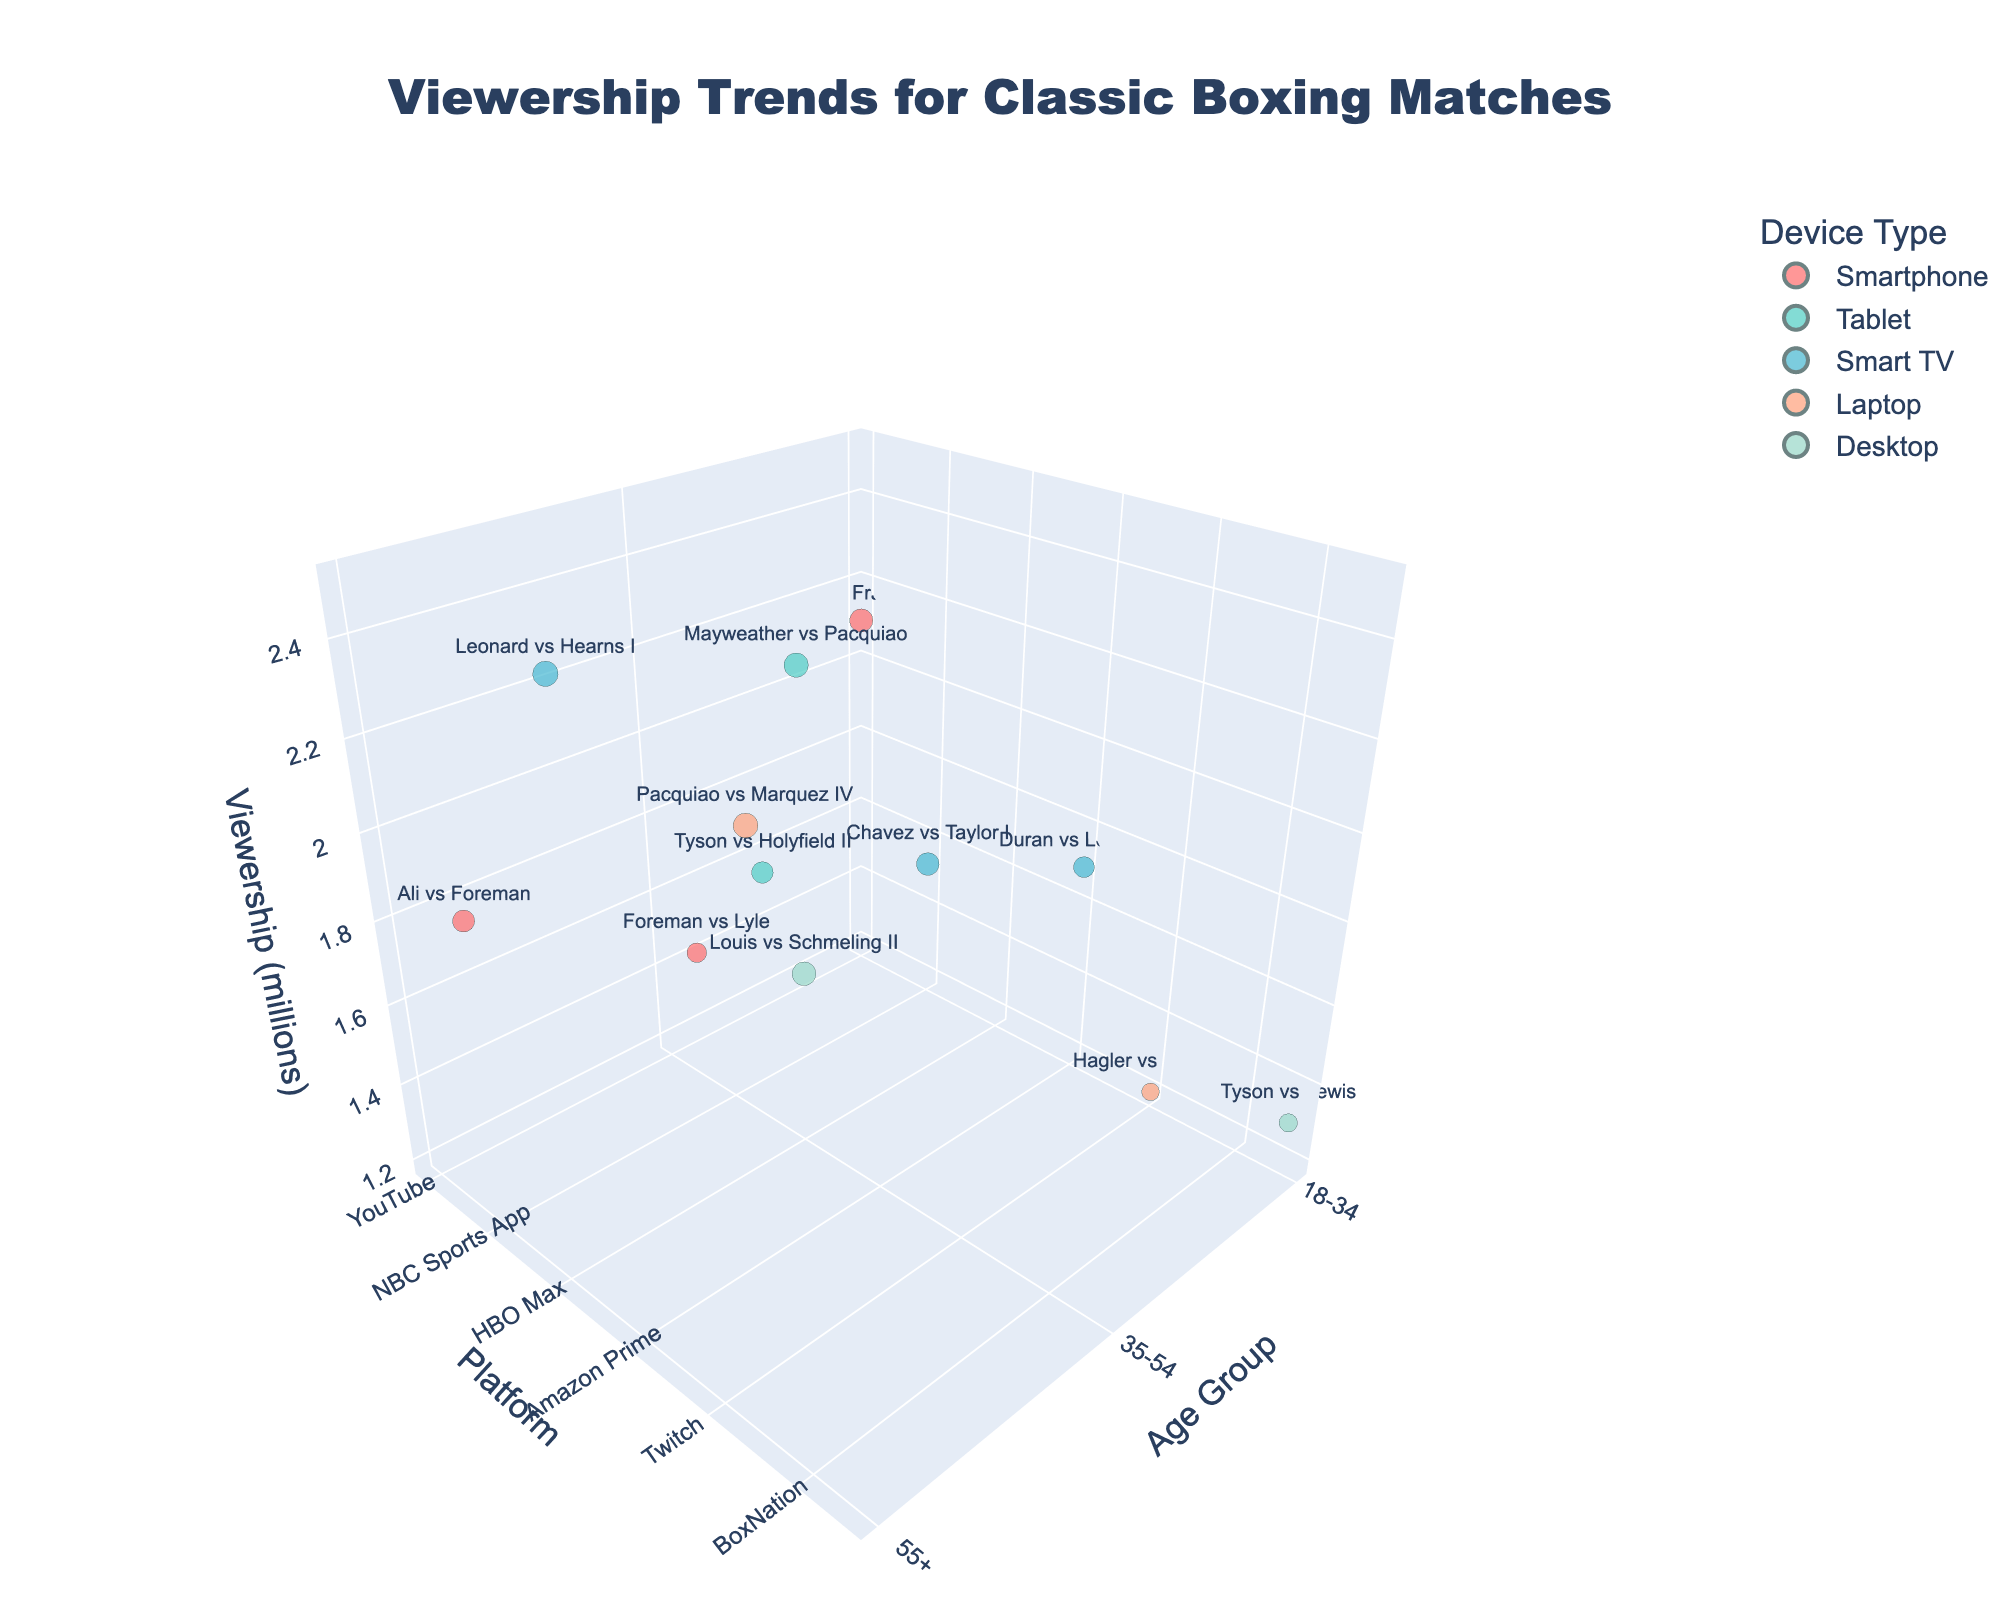What's the title of the figure? The title is prominently displayed at the top center of the figure. It reads "Viewership Trends for Classic Boxing Matches."
Answer: Viewership Trends for Classic Boxing Matches Which age group has the highest viewership for "Leonard vs Hearns I"? By looking at the "Leonard vs Hearns I" label in the 3D space, notice it's in the 55+ age group and the bubble is relatively large.
Answer: 55+ How many platforms are used in the figure? Count the distinct platforms on the y-axis. They are YouTube, ESPN+, DAZN, Twitch, Facebook Watch, HBO Max, NBC Sports App, FuboTV, Hulu, and Sky Sports.
Answer: 10 What is the largest bubble size, and which match does it represent? The largest bubble represents the highest viewership, which is "Leonard vs Hearns I" with 2.5 million viewers.
Answer: Leonard vs Hearns I with 2.5 million viewers Among all the bubbles, which device type has the most frequent representation? By observing the colors of the bubbles, “Smartphone” (represented by red) appears most frequently.
Answer: Smartphone Compare the viewership of "Ali vs Frazier I" and "Hagler vs Hearns" in the 18-34 age group. Which has higher viewership? Check the bubble sizes for "Ali vs Frazier I" (2.1 million) and "Hagler vs Hearns" (1.2 million). "Ali vs Frazier I" has a larger bubble, indicating higher viewership.
Answer: Ali vs Frazier I Which platform among all age groups has the highest represented viewership for a match, and what is that viewership? Identify which platform hosts the match with the largest bubble. "Leonard vs Hearns I" on DAZN has the highest viewership at 2.5 million.
Answer: DAZN, 2.5 million What age group and device type correspond to the match with the smallest bubble? Locate the smallest bubble, which is "Hagler vs Hearns" in the 18-34 age group using a Laptop on Twitch with 1.2 million viewers.
Answer: 18-34, Laptop Which match is the most popular among the 35-54 age group, and on what device type? Find the largest bubble within the 35-54 age group. "Mayweather vs Pacquiao" on HBO Max matches this description with 2.3 million viewers using a Tablet.
Answer: Mayweather vs Pacquiao, Tablet What's the difference in viewership between the most popular match for 55+ and 18-34 groups? The most popular match in 55+ is "Leonard vs Hearns I" (2.5 million) and for 18-34 is "Ali vs Frazier I" (2.1 million). The difference is 2.5 - 2.1 = 0.4 million.
Answer: 0.4 million 